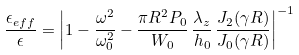Convert formula to latex. <formula><loc_0><loc_0><loc_500><loc_500>\frac { \epsilon _ { e f f } } { \epsilon } = \left | 1 - \frac { \omega ^ { 2 } } { \omega _ { 0 } ^ { 2 } } - \frac { \pi R ^ { 2 } P _ { 0 } } { W _ { 0 } } \, \frac { \lambda _ { z } } { h _ { 0 } } \, \frac { J _ { 2 } ( \gamma R ) } { J _ { 0 } ( \gamma R ) } \right | ^ { - 1 }</formula> 